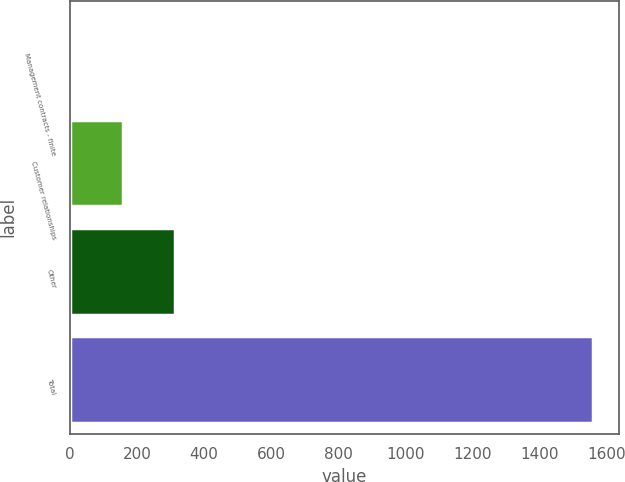Convert chart. <chart><loc_0><loc_0><loc_500><loc_500><bar_chart><fcel>Management contracts - finite<fcel>Customer relationships<fcel>Other<fcel>Total<nl><fcel>2.5<fcel>158.12<fcel>313.74<fcel>1558.7<nl></chart> 